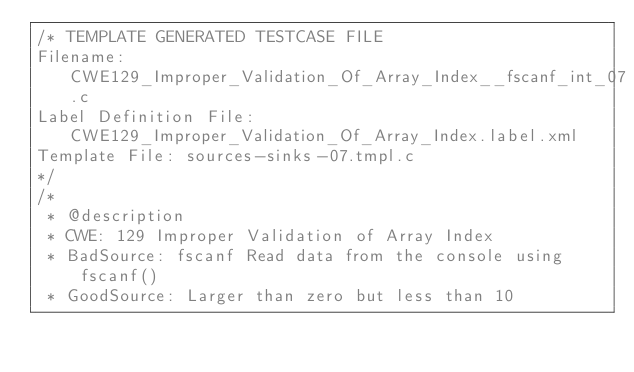Convert code to text. <code><loc_0><loc_0><loc_500><loc_500><_C_>/* TEMPLATE GENERATED TESTCASE FILE
Filename: CWE129_Improper_Validation_Of_Array_Index__fscanf_int_07.c
Label Definition File: CWE129_Improper_Validation_Of_Array_Index.label.xml
Template File: sources-sinks-07.tmpl.c
*/
/*
 * @description
 * CWE: 129 Improper Validation of Array Index
 * BadSource: fscanf Read data from the console using fscanf()
 * GoodSource: Larger than zero but less than 10</code> 